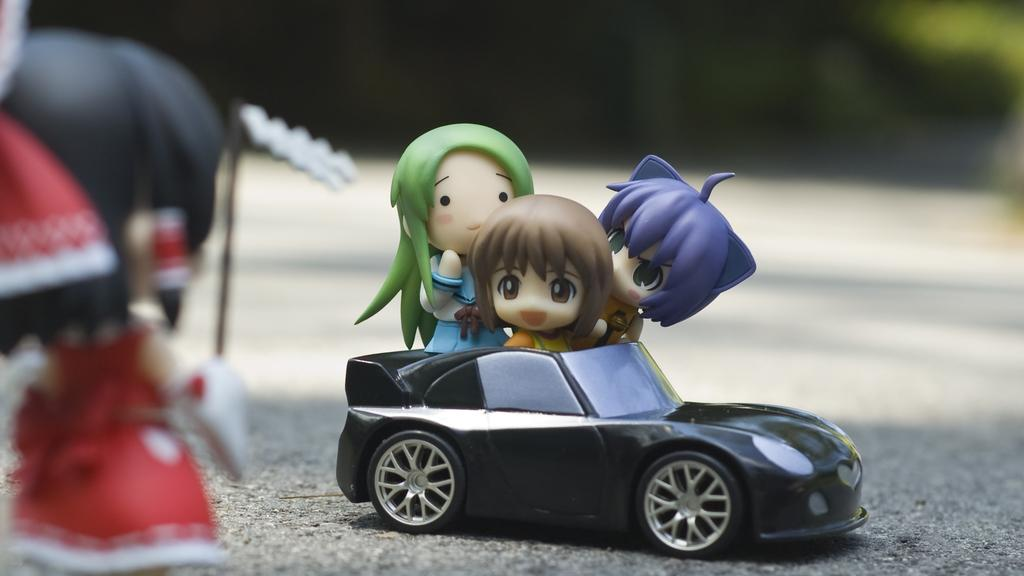What is located in the center of the image? There are toys in the car in the center of the image. Can you describe the toy on the left side of the image? There is another toy on the left side of the image. What industry is depicted in the image? There is no industry depicted in the image; it features toys in a car and another toy on the left side. How many toys are present in the image, considering the fifth toy? There are no mentions of a fifth toy in the image, so we cannot determine the number of toys based on that information. 